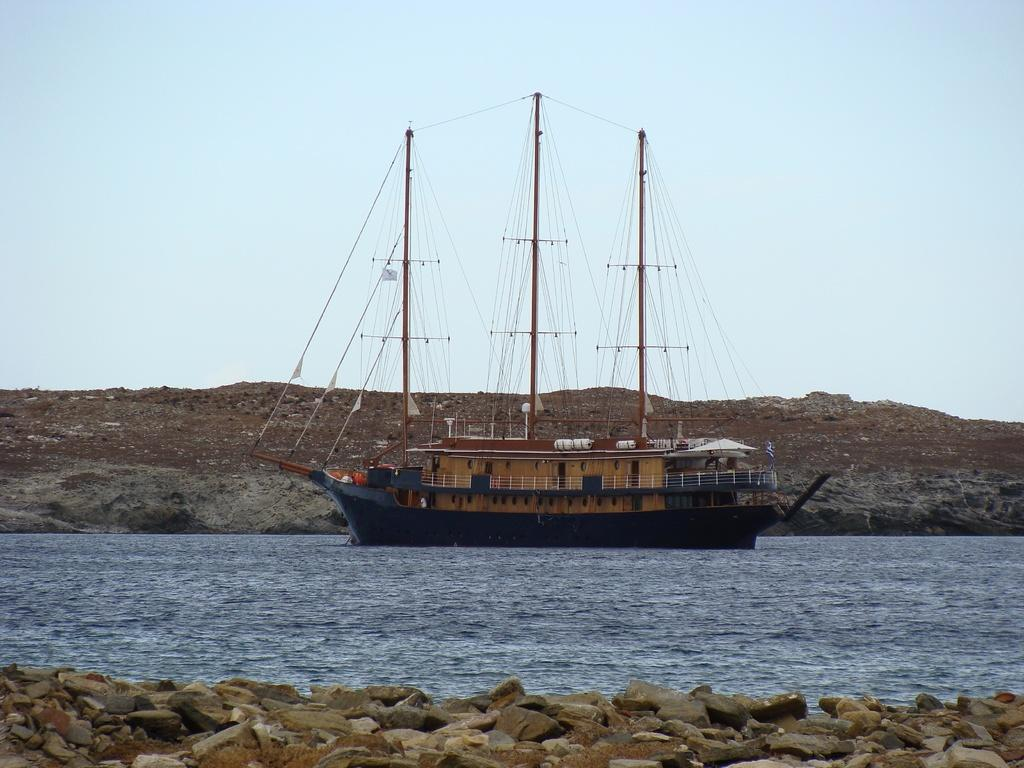What is the main subject of the image? There is a ship in the image. Where is the ship located? The ship is on the water. What type of terrain can be seen in the image? There are stones and soil visible in the image. What is visible in the background of the image? The sky is visible in the background of the image. How many yams are being carried by the ship in the image? There is no indication of yams being present in the image; the ship is on the water with no visible cargo. Can you see a snake slithering on the stones in the image? There is no snake visible in the image; only stones, soil, and the ship are present. 